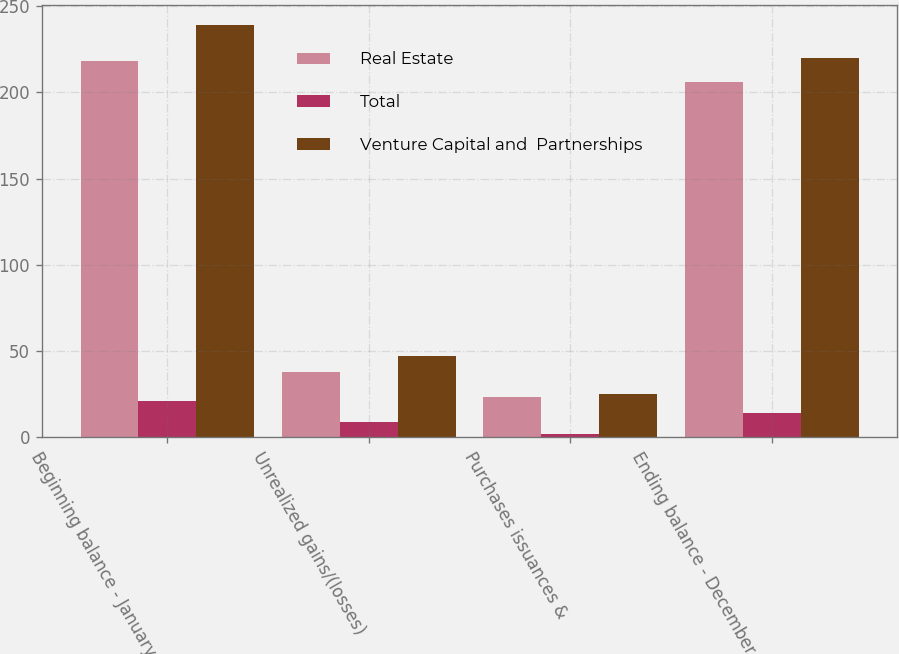Convert chart. <chart><loc_0><loc_0><loc_500><loc_500><stacked_bar_chart><ecel><fcel>Beginning balance - January 1<fcel>Unrealized gains/(losses)<fcel>Purchases issuances &<fcel>Ending balance - December 31<nl><fcel>Real Estate<fcel>218<fcel>38<fcel>23<fcel>206<nl><fcel>Total<fcel>21<fcel>9<fcel>2<fcel>14<nl><fcel>Venture Capital and  Partnerships<fcel>239<fcel>47<fcel>25<fcel>220<nl></chart> 